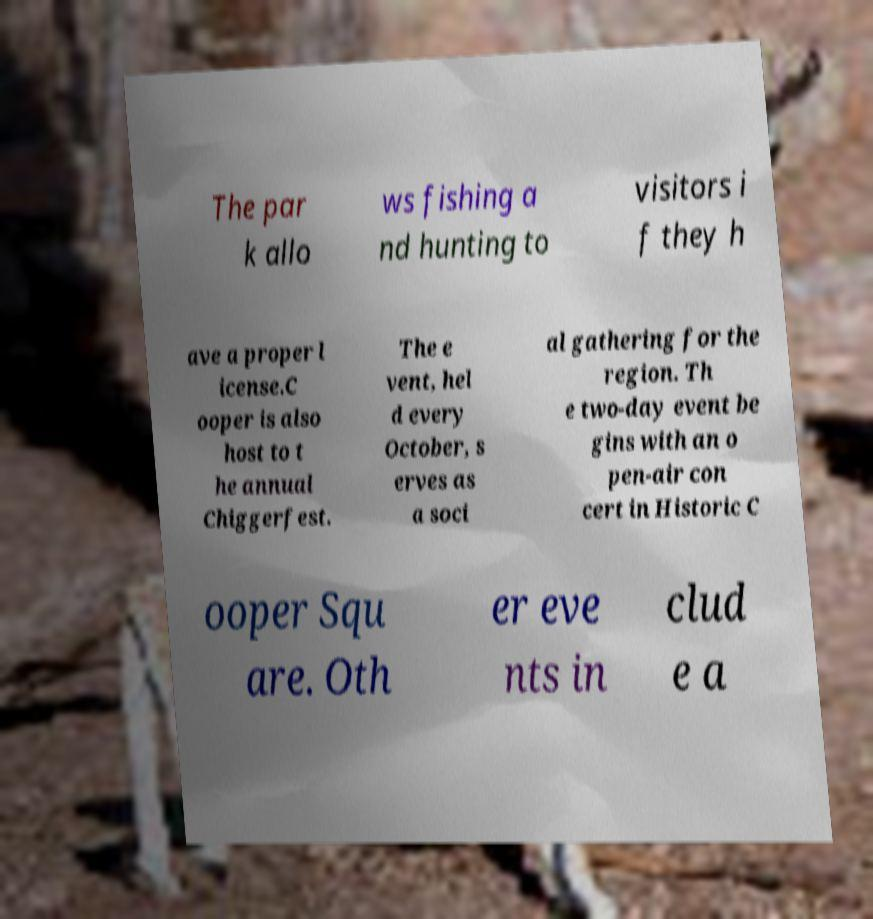Please read and relay the text visible in this image. What does it say? The par k allo ws fishing a nd hunting to visitors i f they h ave a proper l icense.C ooper is also host to t he annual Chiggerfest. The e vent, hel d every October, s erves as a soci al gathering for the region. Th e two-day event be gins with an o pen-air con cert in Historic C ooper Squ are. Oth er eve nts in clud e a 